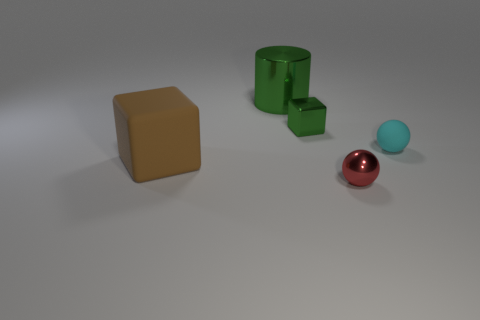Is the number of cyan matte things that are on the left side of the tiny red metal ball less than the number of large brown rubber objects to the left of the brown rubber object?
Offer a terse response. No. What shape is the thing that is both in front of the tiny cyan matte sphere and left of the small red thing?
Provide a short and direct response. Cube. What number of other large matte objects have the same shape as the brown thing?
Offer a very short reply. 0. There is a cylinder that is the same material as the small red object; what is its size?
Provide a short and direct response. Large. What number of red metallic things are the same size as the cyan sphere?
Provide a short and direct response. 1. What size is the metal cube that is the same color as the shiny cylinder?
Ensure brevity in your answer.  Small. What is the color of the metallic thing in front of the matte thing that is behind the big brown matte thing?
Offer a terse response. Red. Are there any small rubber spheres that have the same color as the small cube?
Provide a succinct answer. No. What color is the shiny cylinder that is the same size as the brown cube?
Your response must be concise. Green. Are the object that is left of the large green metal cylinder and the small cyan sphere made of the same material?
Give a very brief answer. Yes. 